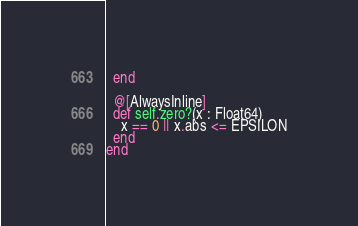Convert code to text. <code><loc_0><loc_0><loc_500><loc_500><_Crystal_>  end

  @[AlwaysInline]
  def self.zero?(x : Float64)
    x == 0 || x.abs <= EPSILON
  end
end
</code> 